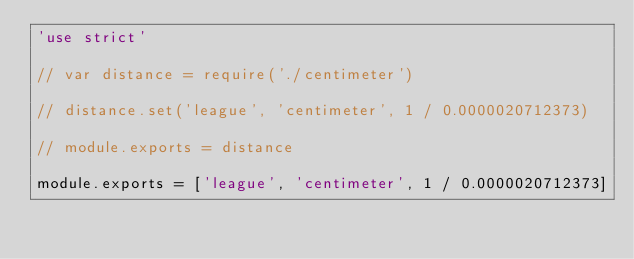<code> <loc_0><loc_0><loc_500><loc_500><_JavaScript_>'use strict'

// var distance = require('./centimeter')

// distance.set('league', 'centimeter', 1 / 0.0000020712373)

// module.exports = distance

module.exports = ['league', 'centimeter', 1 / 0.0000020712373]
</code> 